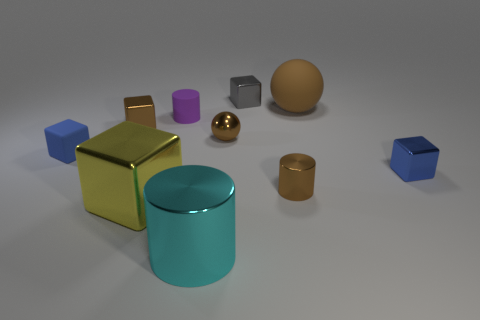Do you see any patterns or themes in the arrangement of the objects? One can observe a theme of geometric shapes and contrasting textures. The objects are arranged in a way that juxtaposes shiny and matte finishes while showcasing a variety of shapes like cubes, cylinders, and spheres. 